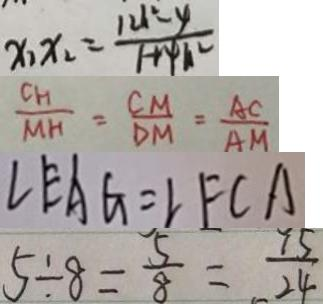Convert formula to latex. <formula><loc_0><loc_0><loc_500><loc_500>x _ { 1 } x _ { 2 } = \frac { 1 2 h ^ { 2 } - y } { 1 + 4 h ^ { 2 } } 
 \frac { G _ { H } } { M H } = \frac { C M } { D M } = \frac { A C } { A M } 
 \angle E A G = \angle F C A 
 5 \div 8 = \frac { 5 } { 8 } = \frac { 1 5 } { 2 4 }</formula> 